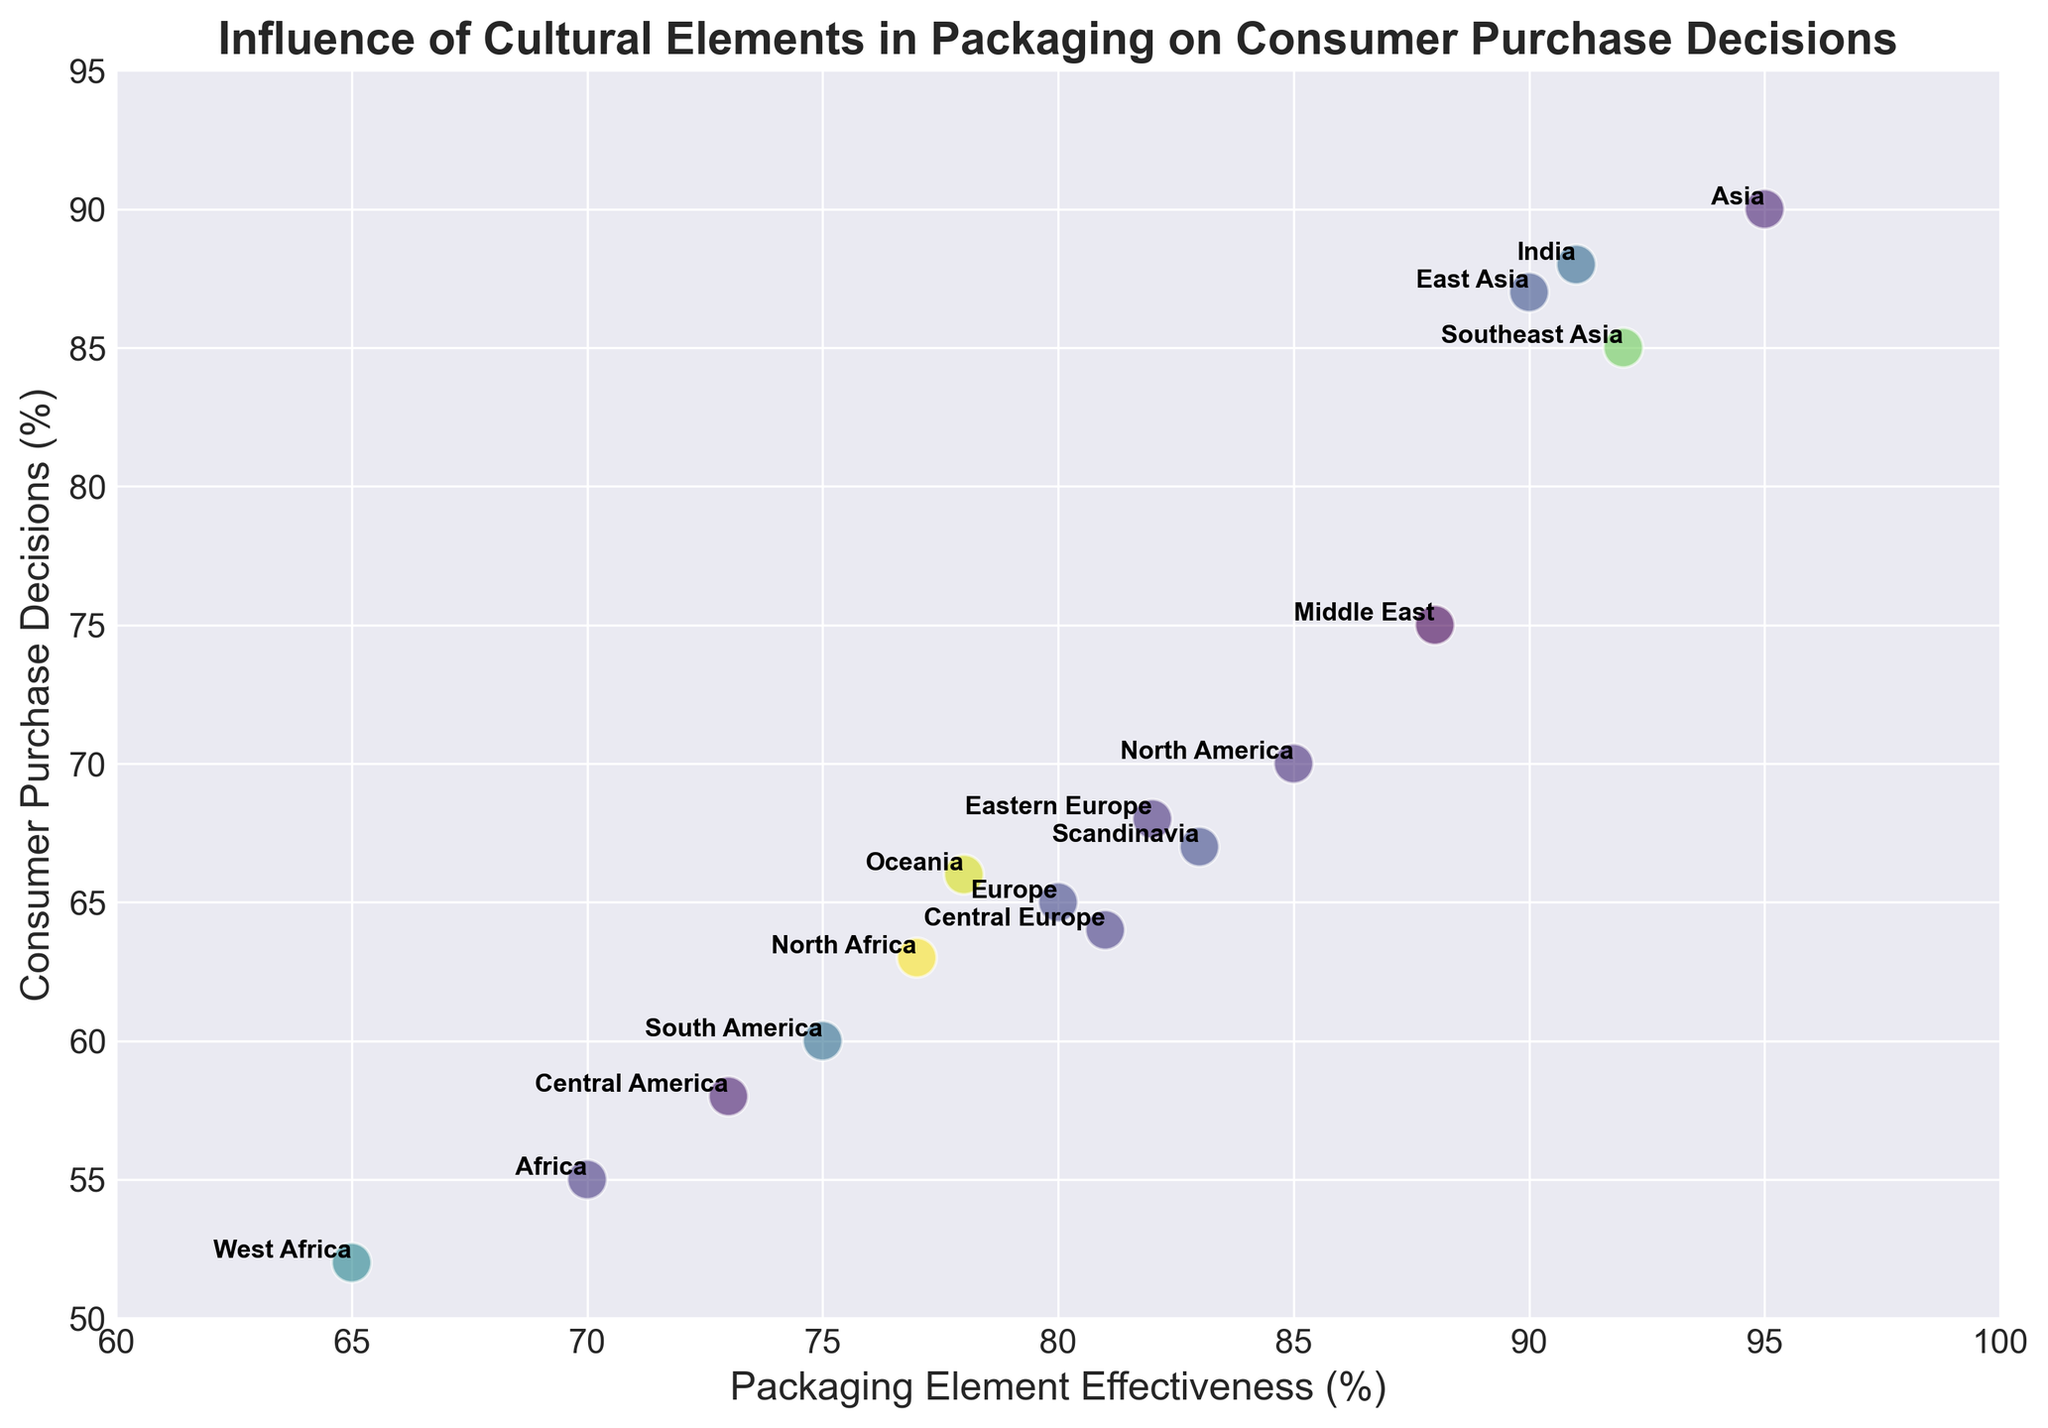Where is the data point with the highest Consumer Purchase Decision located? The point with the highest Consumer Purchase Decision percentile is in Asia (90%). Examine the figure and identify the highest point on the y-axis, which points to Asia.
Answer: Asia Which region has the lowest Packaging Element Effectiveness and what is its Consumer Purchase Decision? The region with the lowest Packaging Element Effectiveness is West Africa (65%). Look for the data point farthest left on the x-axis and then check its y-value.
Answer: West Africa, 52 Which regions have Packaging Element Effectiveness percentages greater than 90%? The regions with Packaging Element Effectiveness rates greater than 90% include Asia, Southeast Asia, India, and East Asia. Identify all points with x-values exceeding 90%.
Answer: Asia, Southeast Asia, India, East Asia Compare the Consumer Purchase Decisions of North Africa and Central Europe. Which region has a higher percentage? North Africa has a Consumer Purchase Decision percentage of 63%, while Central Europe has 64%. Locate both data points on the y-axis and compare them.
Answer: Central Europe What is the average Packaging Element Effectiveness for the regions with Consumer Purchase Decisions above 80%? Determine which regions have Consumer Purchase Decisions over 80% (Asia, Southeast Asia, India, and East Asia) and calculate the average of their Packaging Element Effectiveness values: (95 + 92 + 91 + 90) / 4 = 92.
Answer: 92 Are there any visual differences in the colors of the points representing the Middle East and Scandinavia? The plotted points for the Middle East and Scandinavia appear in different colors due to the color-coding based on numerical values. Refer to the color legend on the figure to distinguish the shades employed.
Answer: Yes Identify the region with the closest Consumer Purchase Decision to that of North America. North America's Consumer Purchase Decision is 70%. From the figure, Europe has a Consumer Purchase Decision of 65%, which is the nearest to North America's value.
Answer: Europe Calculate the difference in Packaging Element Effectiveness between South America and Oceania. South America's Packaging Element Effectiveness is 75%, while Oceania's is 78%. The difference is computed as 78 - 75 = 3%.
Answer: 3 Which regions fall within the 80-85% range of Packaging Element Effectiveness? The regions within the 80-85% range of Packaging Element Effectiveness are Europe (80%), Middle East (88%), Scandinavia (83%), and Central Europe (81%). Observe and identify points that fall between these x-values.
Answer: Europe, Middle East, Scandinavia, Central Europe 